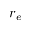<formula> <loc_0><loc_0><loc_500><loc_500>r _ { e }</formula> 